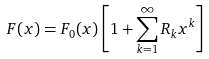Convert formula to latex. <formula><loc_0><loc_0><loc_500><loc_500>F ( x ) = F _ { 0 } ( x ) \left [ 1 + \sum _ { k = 1 } ^ { \infty } R _ { k } x ^ { k } \right ]</formula> 